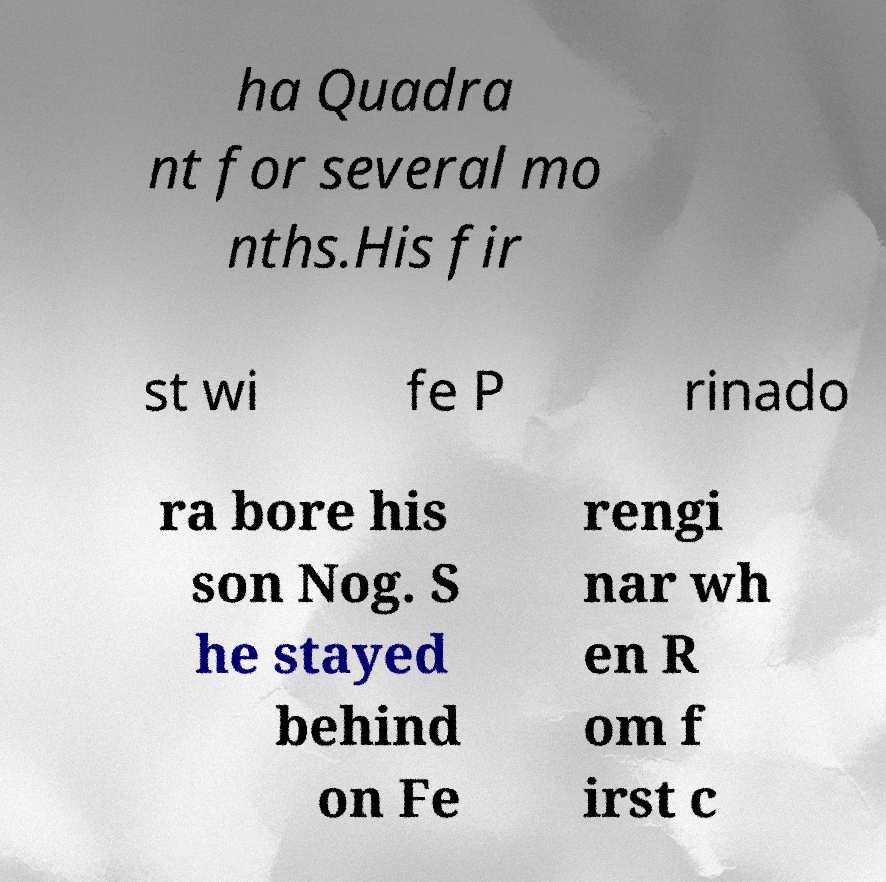I need the written content from this picture converted into text. Can you do that? ha Quadra nt for several mo nths.His fir st wi fe P rinado ra bore his son Nog. S he stayed behind on Fe rengi nar wh en R om f irst c 